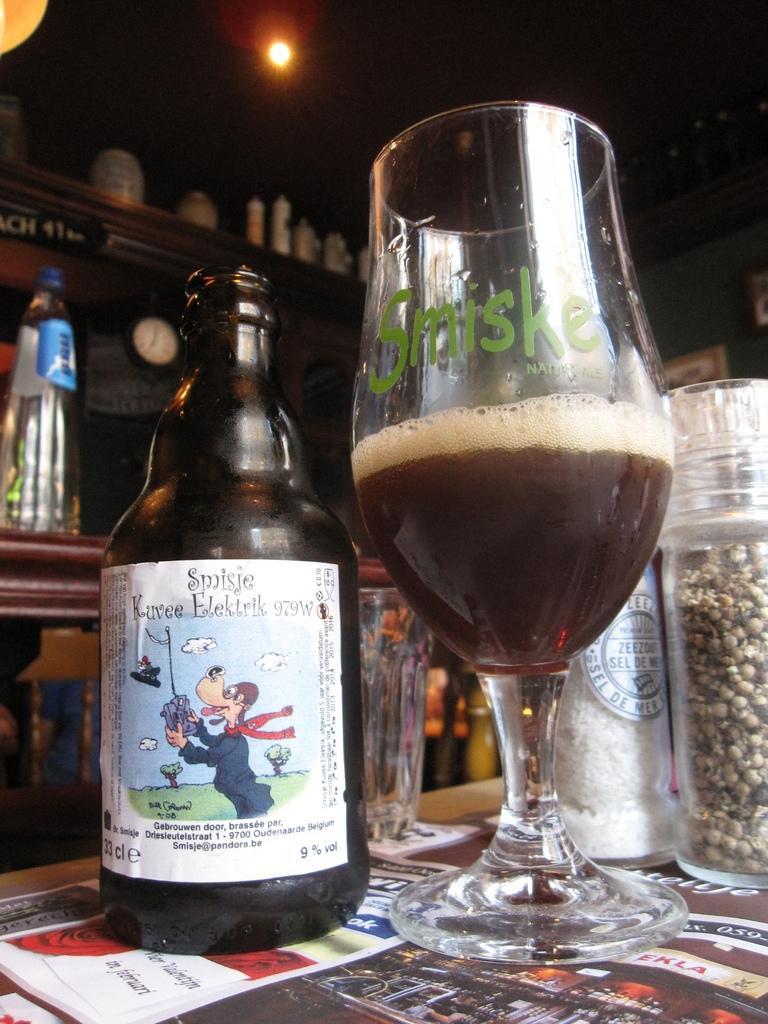How would you summarize this image in a sentence or two? There is a wine bottle,glass on a table. In the background there are bottles,light. 